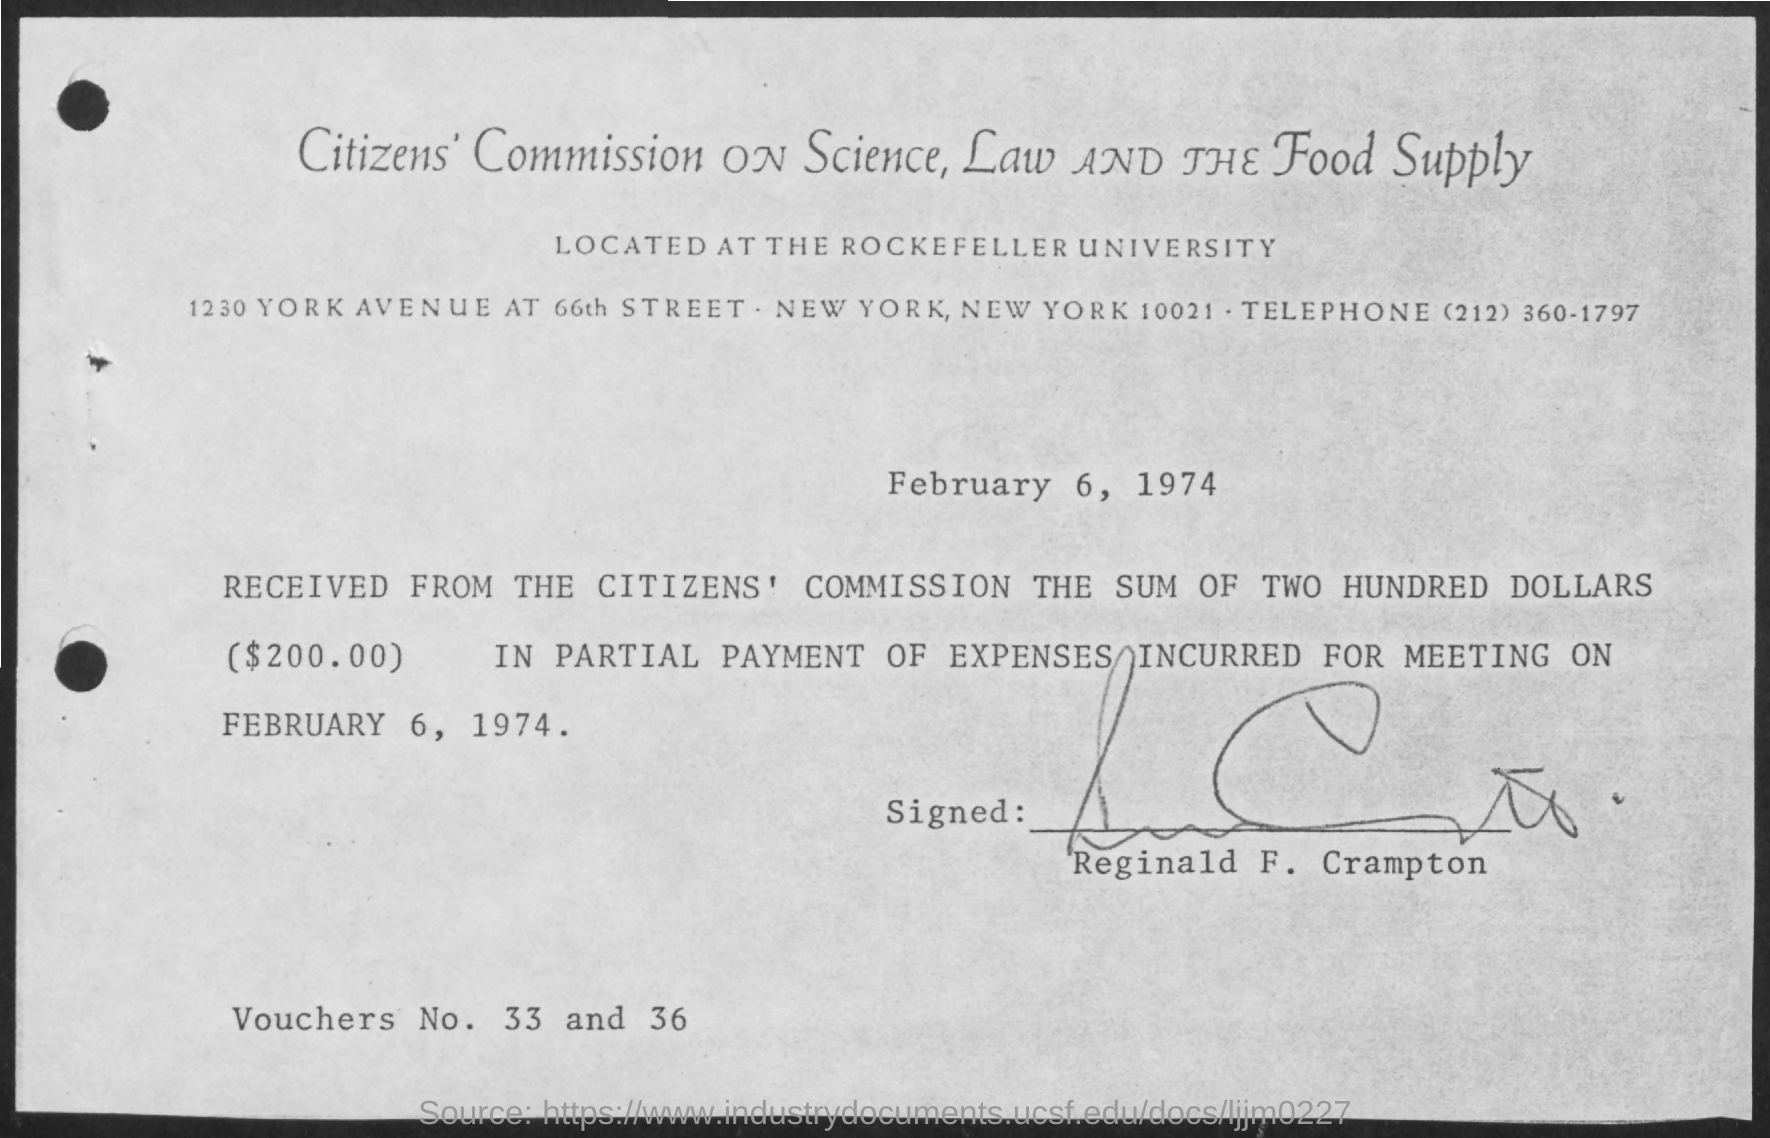What is the amount received from the Citizen's Commission?
Keep it short and to the point. ($2000.00). What are the vouchers No. given?
Offer a very short reply. 33 and 36. Who has signed this acknowledgement?
Offer a very short reply. Reginald F. Crampton. What is this document dated?
Provide a succinct answer. February 6, 1974. 